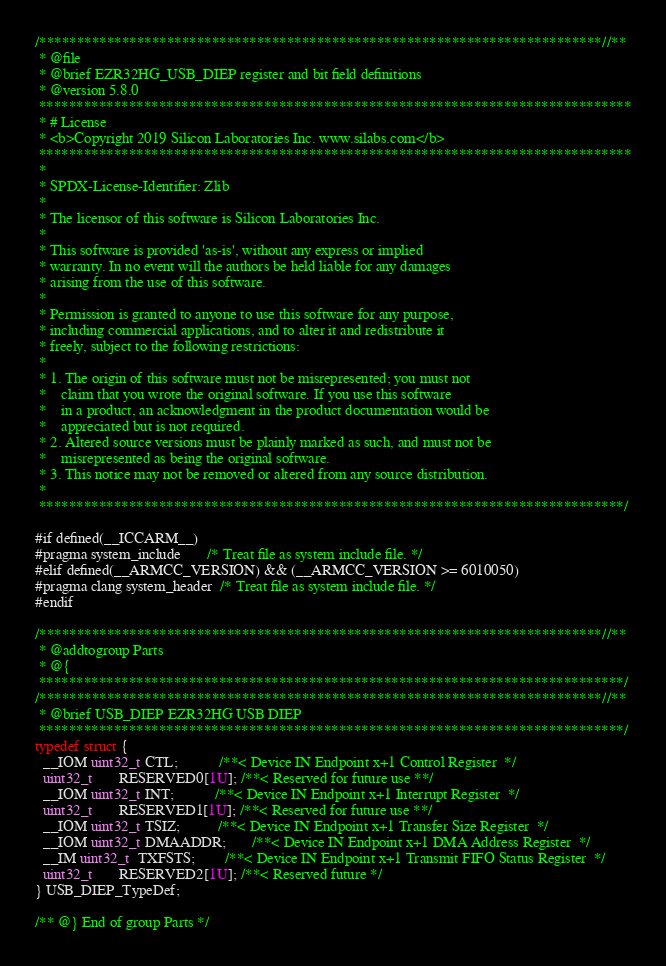Convert code to text. <code><loc_0><loc_0><loc_500><loc_500><_C_>/***************************************************************************//**
 * @file
 * @brief EZR32HG_USB_DIEP register and bit field definitions
 * @version 5.8.0
 *******************************************************************************
 * # License
 * <b>Copyright 2019 Silicon Laboratories Inc. www.silabs.com</b>
 *******************************************************************************
 *
 * SPDX-License-Identifier: Zlib
 *
 * The licensor of this software is Silicon Laboratories Inc.
 *
 * This software is provided 'as-is', without any express or implied
 * warranty. In no event will the authors be held liable for any damages
 * arising from the use of this software.
 *
 * Permission is granted to anyone to use this software for any purpose,
 * including commercial applications, and to alter it and redistribute it
 * freely, subject to the following restrictions:
 *
 * 1. The origin of this software must not be misrepresented; you must not
 *    claim that you wrote the original software. If you use this software
 *    in a product, an acknowledgment in the product documentation would be
 *    appreciated but is not required.
 * 2. Altered source versions must be plainly marked as such, and must not be
 *    misrepresented as being the original software.
 * 3. This notice may not be removed or altered from any source distribution.
 *
 ******************************************************************************/

#if defined(__ICCARM__)
#pragma system_include       /* Treat file as system include file. */
#elif defined(__ARMCC_VERSION) && (__ARMCC_VERSION >= 6010050)
#pragma clang system_header  /* Treat file as system include file. */
#endif

/***************************************************************************//**
 * @addtogroup Parts
 * @{
 ******************************************************************************/
/***************************************************************************//**
 * @brief USB_DIEP EZR32HG USB DIEP
 ******************************************************************************/
typedef struct {
  __IOM uint32_t CTL;           /**< Device IN Endpoint x+1 Control Register  */
  uint32_t       RESERVED0[1U]; /**< Reserved for future use **/
  __IOM uint32_t INT;           /**< Device IN Endpoint x+1 Interrupt Register  */
  uint32_t       RESERVED1[1U]; /**< Reserved for future use **/
  __IOM uint32_t TSIZ;          /**< Device IN Endpoint x+1 Transfer Size Register  */
  __IOM uint32_t DMAADDR;       /**< Device IN Endpoint x+1 DMA Address Register  */
  __IM uint32_t  TXFSTS;        /**< Device IN Endpoint x+1 Transmit FIFO Status Register  */
  uint32_t       RESERVED2[1U]; /**< Reserved future */
} USB_DIEP_TypeDef;

/** @} End of group Parts */
</code> 